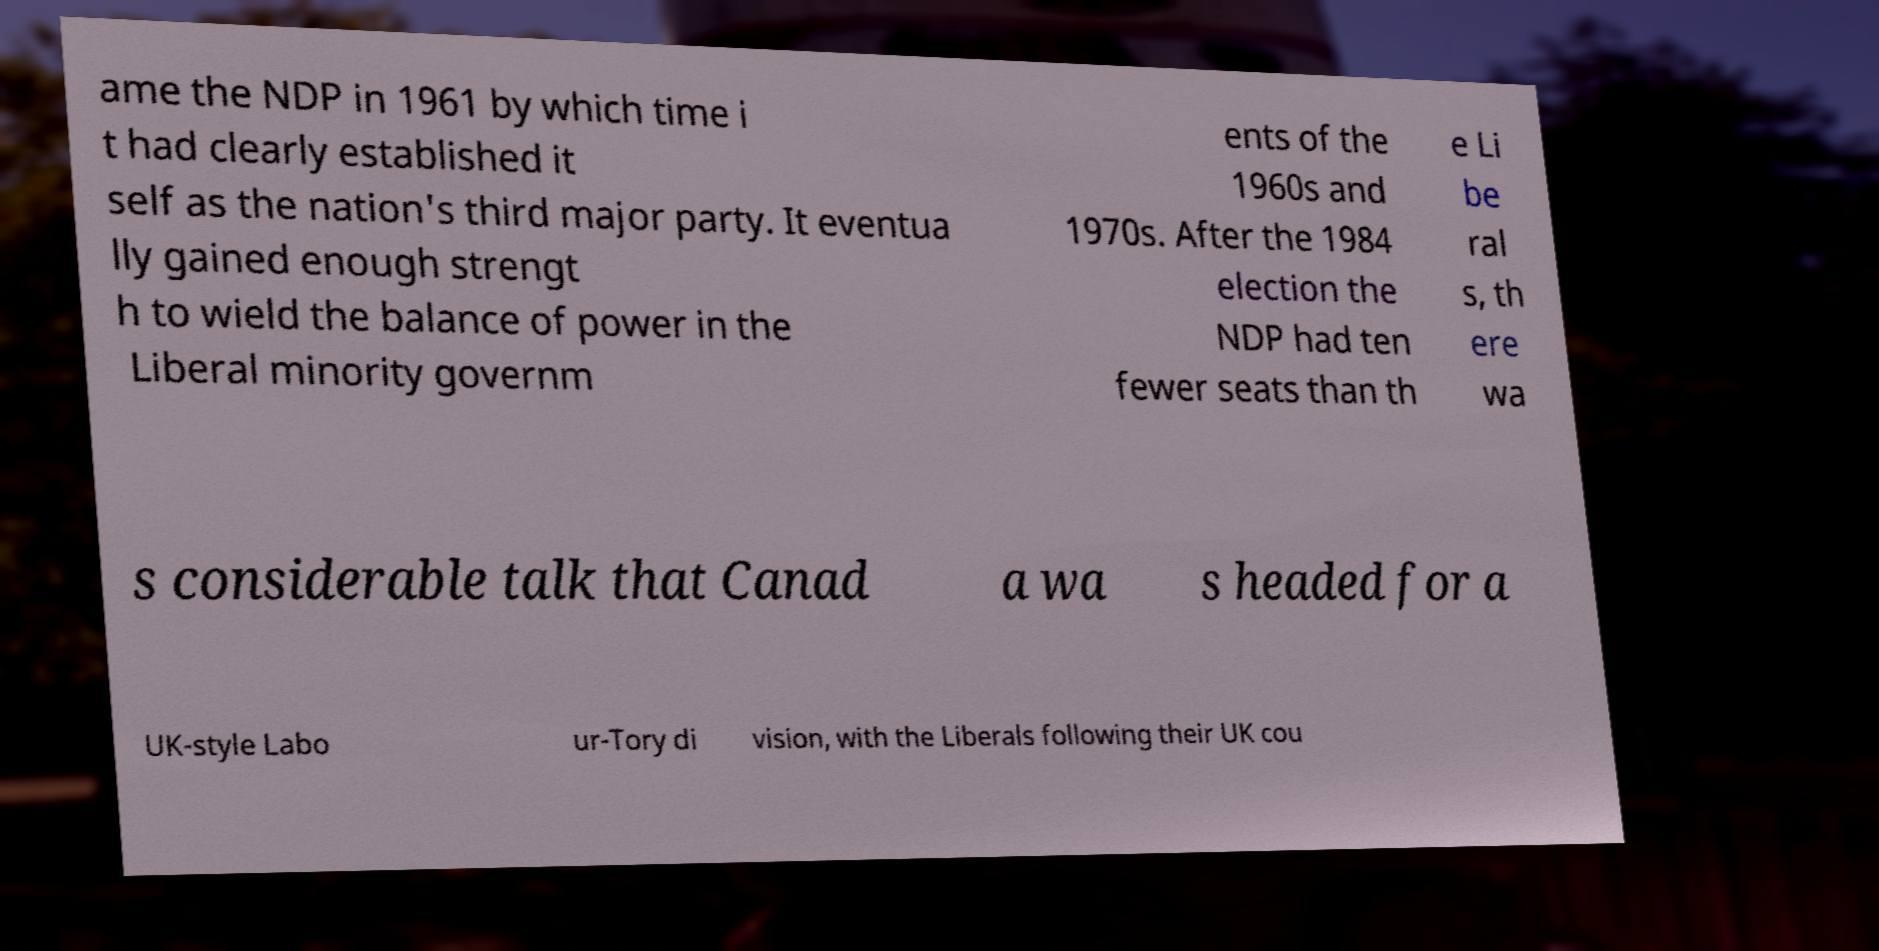I need the written content from this picture converted into text. Can you do that? ame the NDP in 1961 by which time i t had clearly established it self as the nation's third major party. It eventua lly gained enough strengt h to wield the balance of power in the Liberal minority governm ents of the 1960s and 1970s. After the 1984 election the NDP had ten fewer seats than th e Li be ral s, th ere wa s considerable talk that Canad a wa s headed for a UK-style Labo ur-Tory di vision, with the Liberals following their UK cou 